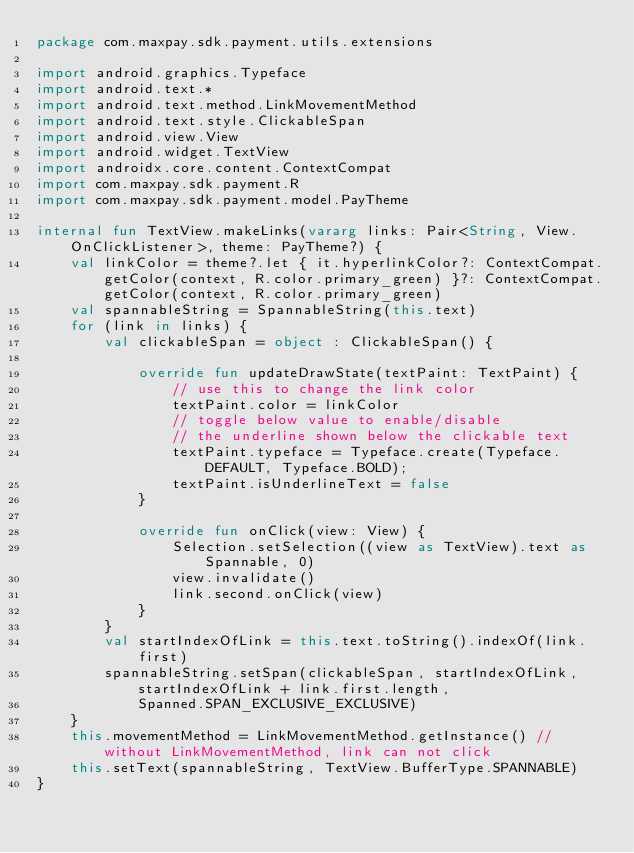<code> <loc_0><loc_0><loc_500><loc_500><_Kotlin_>package com.maxpay.sdk.payment.utils.extensions

import android.graphics.Typeface
import android.text.*
import android.text.method.LinkMovementMethod
import android.text.style.ClickableSpan
import android.view.View
import android.widget.TextView
import androidx.core.content.ContextCompat
import com.maxpay.sdk.payment.R
import com.maxpay.sdk.payment.model.PayTheme

internal fun TextView.makeLinks(vararg links: Pair<String, View.OnClickListener>, theme: PayTheme?) {
    val linkColor = theme?.let { it.hyperlinkColor?: ContextCompat.getColor(context, R.color.primary_green) }?: ContextCompat.getColor(context, R.color.primary_green)
    val spannableString = SpannableString(this.text)
    for (link in links) {
        val clickableSpan = object : ClickableSpan() {

            override fun updateDrawState(textPaint: TextPaint) {
                // use this to change the link color
                textPaint.color = linkColor
                // toggle below value to enable/disable
                // the underline shown below the clickable text
                textPaint.typeface = Typeface.create(Typeface.DEFAULT, Typeface.BOLD);
                textPaint.isUnderlineText = false
            }

            override fun onClick(view: View) {
                Selection.setSelection((view as TextView).text as Spannable, 0)
                view.invalidate()
                link.second.onClick(view)
            }
        }
        val startIndexOfLink = this.text.toString().indexOf(link.first)
        spannableString.setSpan(clickableSpan, startIndexOfLink, startIndexOfLink + link.first.length,
            Spanned.SPAN_EXCLUSIVE_EXCLUSIVE)
    }
    this.movementMethod = LinkMovementMethod.getInstance() // without LinkMovementMethod, link can not click
    this.setText(spannableString, TextView.BufferType.SPANNABLE)
}</code> 